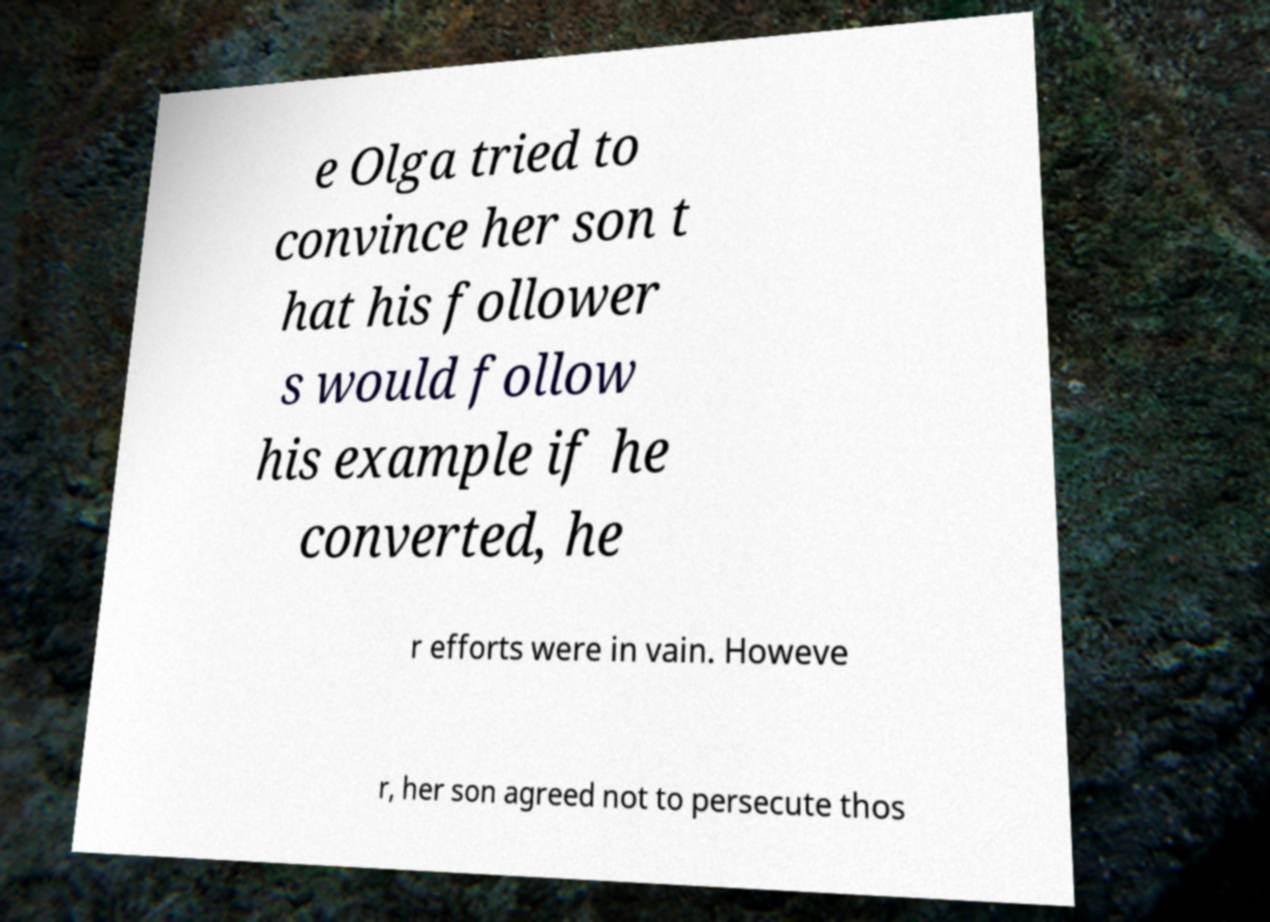What messages or text are displayed in this image? I need them in a readable, typed format. e Olga tried to convince her son t hat his follower s would follow his example if he converted, he r efforts were in vain. Howeve r, her son agreed not to persecute thos 